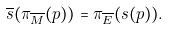<formula> <loc_0><loc_0><loc_500><loc_500>\overline { s } ( \pi _ { \overline { M } } ( p ) ) = \pi _ { \overline { E } } ( s ( p ) ) .</formula> 